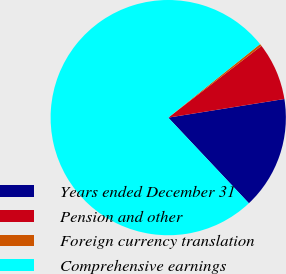<chart> <loc_0><loc_0><loc_500><loc_500><pie_chart><fcel>Years ended December 31<fcel>Pension and other<fcel>Foreign currency translation<fcel>Comprehensive earnings<nl><fcel>15.51%<fcel>7.91%<fcel>0.31%<fcel>76.27%<nl></chart> 